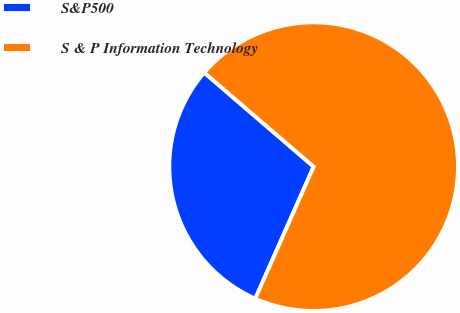Convert chart to OTSL. <chart><loc_0><loc_0><loc_500><loc_500><pie_chart><fcel>S&P500<fcel>S & P Information Technology<nl><fcel>29.67%<fcel>70.33%<nl></chart> 